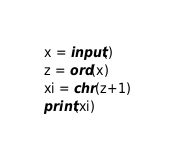<code> <loc_0><loc_0><loc_500><loc_500><_Python_>x = input()
z = ord(x)
xi = chr(z+1)
print(xi)</code> 